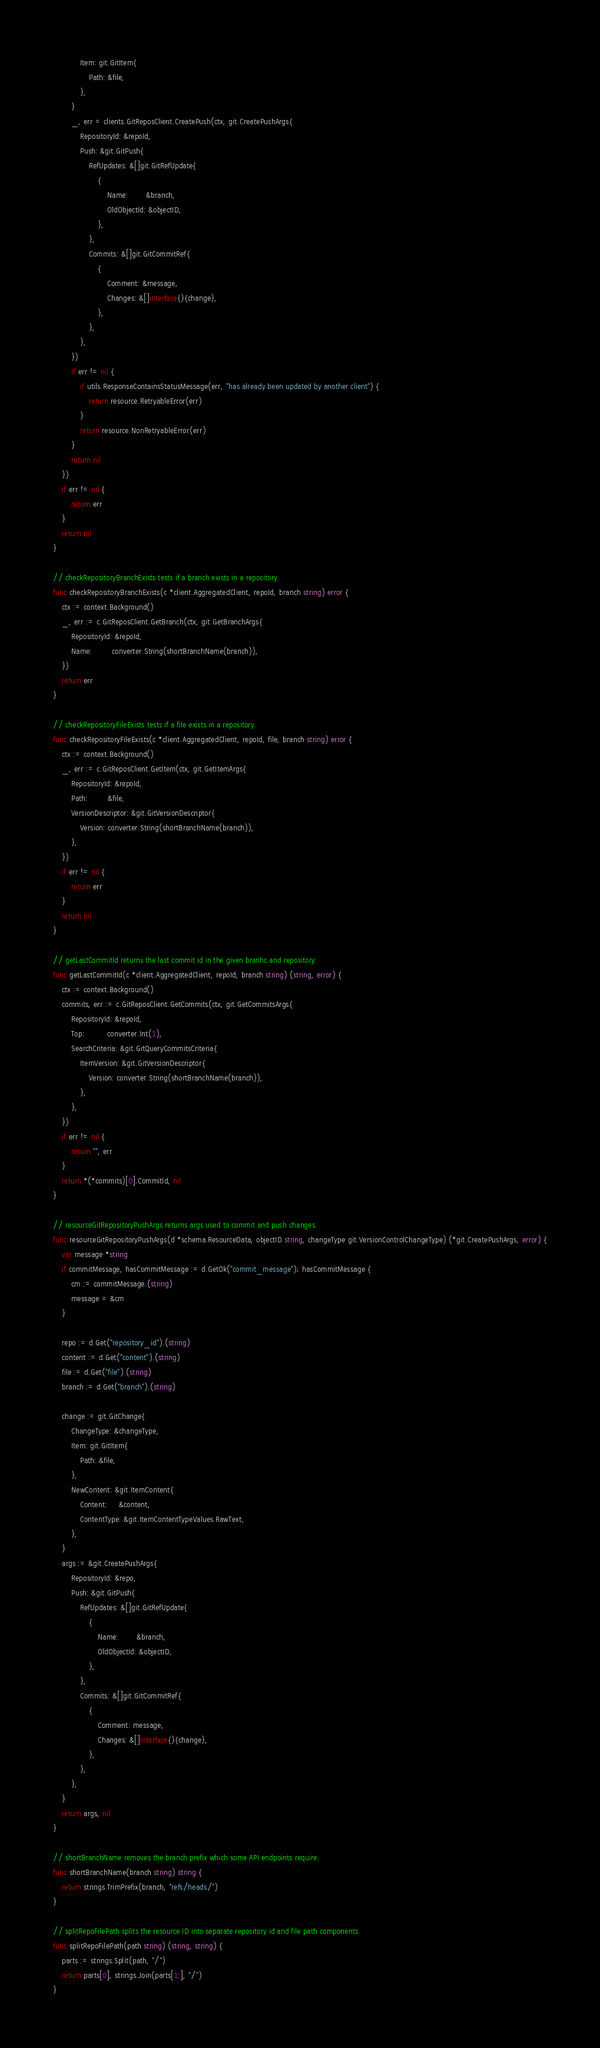<code> <loc_0><loc_0><loc_500><loc_500><_Go_>			Item: git.GitItem{
				Path: &file,
			},
		}
		_, err = clients.GitReposClient.CreatePush(ctx, git.CreatePushArgs{
			RepositoryId: &repoId,
			Push: &git.GitPush{
				RefUpdates: &[]git.GitRefUpdate{
					{
						Name:        &branch,
						OldObjectId: &objectID,
					},
				},
				Commits: &[]git.GitCommitRef{
					{
						Comment: &message,
						Changes: &[]interface{}{change},
					},
				},
			},
		})
		if err != nil {
			if utils.ResponseContainsStatusMessage(err, "has already been updated by another client") {
				return resource.RetryableError(err)
			}
			return resource.NonRetryableError(err)
		}
		return nil
	})
	if err != nil {
		return err
	}
	return nil
}

// checkRepositoryBranchExists tests if a branch exists in a repository.
func checkRepositoryBranchExists(c *client.AggregatedClient, repoId, branch string) error {
	ctx := context.Background()
	_, err := c.GitReposClient.GetBranch(ctx, git.GetBranchArgs{
		RepositoryId: &repoId,
		Name:         converter.String(shortBranchName(branch)),
	})
	return err
}

// checkRepositoryFileExists tests if a file exists in a repository.
func checkRepositoryFileExists(c *client.AggregatedClient, repoId, file, branch string) error {
	ctx := context.Background()
	_, err := c.GitReposClient.GetItem(ctx, git.GetItemArgs{
		RepositoryId: &repoId,
		Path:         &file,
		VersionDescriptor: &git.GitVersionDescriptor{
			Version: converter.String(shortBranchName(branch)),
		},
	})
	if err != nil {
		return err
	}
	return nil
}

// getLastCommitId returns the last commit id in the given branhc and repository.
func getLastCommitId(c *client.AggregatedClient, repoId, branch string) (string, error) {
	ctx := context.Background()
	commits, err := c.GitReposClient.GetCommits(ctx, git.GetCommitsArgs{
		RepositoryId: &repoId,
		Top:          converter.Int(1),
		SearchCriteria: &git.GitQueryCommitsCriteria{
			ItemVersion: &git.GitVersionDescriptor{
				Version: converter.String(shortBranchName(branch)),
			},
		},
	})
	if err != nil {
		return "", err
	}
	return *(*commits)[0].CommitId, nil
}

// resourceGitRepositoryPushArgs returns args used to commit and push changes.
func resourceGitRepositoryPushArgs(d *schema.ResourceData, objectID string, changeType git.VersionControlChangeType) (*git.CreatePushArgs, error) {
	var message *string
	if commitMessage, hasCommitMessage := d.GetOk("commit_message"); hasCommitMessage {
		cm := commitMessage.(string)
		message = &cm
	}

	repo := d.Get("repository_id").(string)
	content := d.Get("content").(string)
	file := d.Get("file").(string)
	branch := d.Get("branch").(string)

	change := git.GitChange{
		ChangeType: &changeType,
		Item: git.GitItem{
			Path: &file,
		},
		NewContent: &git.ItemContent{
			Content:     &content,
			ContentType: &git.ItemContentTypeValues.RawText,
		},
	}
	args := &git.CreatePushArgs{
		RepositoryId: &repo,
		Push: &git.GitPush{
			RefUpdates: &[]git.GitRefUpdate{
				{
					Name:        &branch,
					OldObjectId: &objectID,
				},
			},
			Commits: &[]git.GitCommitRef{
				{
					Comment: message,
					Changes: &[]interface{}{change},
				},
			},
		},
	}
	return args, nil
}

// shortBranchName removes the branch prefix which some API endpoints require.
func shortBranchName(branch string) string {
	return strings.TrimPrefix(branch, "refs/heads/")
}

// splitRepoFilePath splits the resource ID into separate repository id and file path components.
func splitRepoFilePath(path string) (string, string) {
	parts := strings.Split(path, "/")
	return parts[0], strings.Join(parts[1:], "/")
}
</code> 